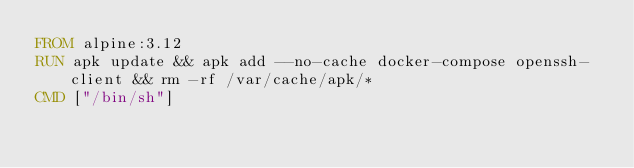<code> <loc_0><loc_0><loc_500><loc_500><_Dockerfile_>FROM alpine:3.12
RUN apk update && apk add --no-cache docker-compose openssh-client && rm -rf /var/cache/apk/*
CMD ["/bin/sh"]
</code> 